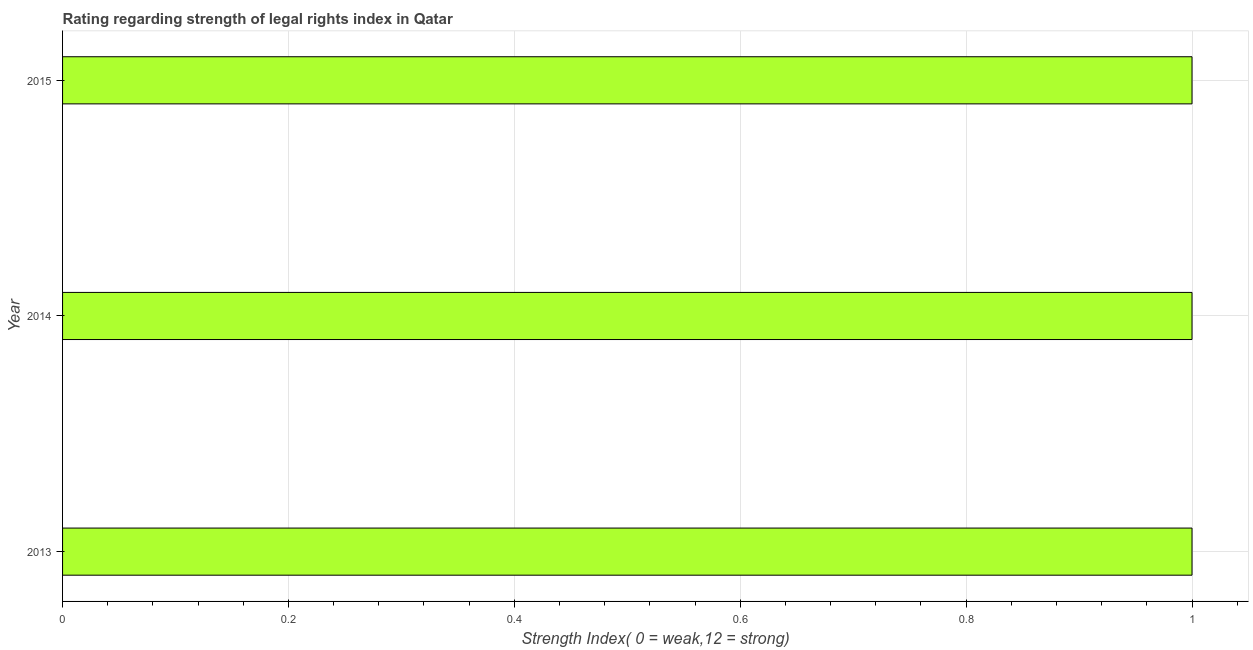Does the graph contain any zero values?
Provide a short and direct response. No. Does the graph contain grids?
Keep it short and to the point. Yes. What is the title of the graph?
Your response must be concise. Rating regarding strength of legal rights index in Qatar. What is the label or title of the X-axis?
Your response must be concise. Strength Index( 0 = weak,12 = strong). What is the label or title of the Y-axis?
Your answer should be compact. Year. In which year was the strength of legal rights index minimum?
Provide a short and direct response. 2013. What is the sum of the strength of legal rights index?
Give a very brief answer. 3. What is the difference between the strength of legal rights index in 2013 and 2015?
Keep it short and to the point. 0. What is the average strength of legal rights index per year?
Make the answer very short. 1. What is the median strength of legal rights index?
Your answer should be compact. 1. Do a majority of the years between 2014 and 2013 (inclusive) have strength of legal rights index greater than 0.92 ?
Provide a succinct answer. No. What is the ratio of the strength of legal rights index in 2013 to that in 2014?
Your answer should be very brief. 1. Is the strength of legal rights index in 2014 less than that in 2015?
Your response must be concise. No. Is the difference between the strength of legal rights index in 2013 and 2014 greater than the difference between any two years?
Give a very brief answer. Yes. What is the difference between the highest and the second highest strength of legal rights index?
Provide a short and direct response. 0. What is the difference between the highest and the lowest strength of legal rights index?
Keep it short and to the point. 0. In how many years, is the strength of legal rights index greater than the average strength of legal rights index taken over all years?
Give a very brief answer. 0. How many bars are there?
Make the answer very short. 3. What is the Strength Index( 0 = weak,12 = strong) of 2014?
Keep it short and to the point. 1. What is the difference between the Strength Index( 0 = weak,12 = strong) in 2014 and 2015?
Ensure brevity in your answer.  0. What is the ratio of the Strength Index( 0 = weak,12 = strong) in 2013 to that in 2014?
Your response must be concise. 1. 